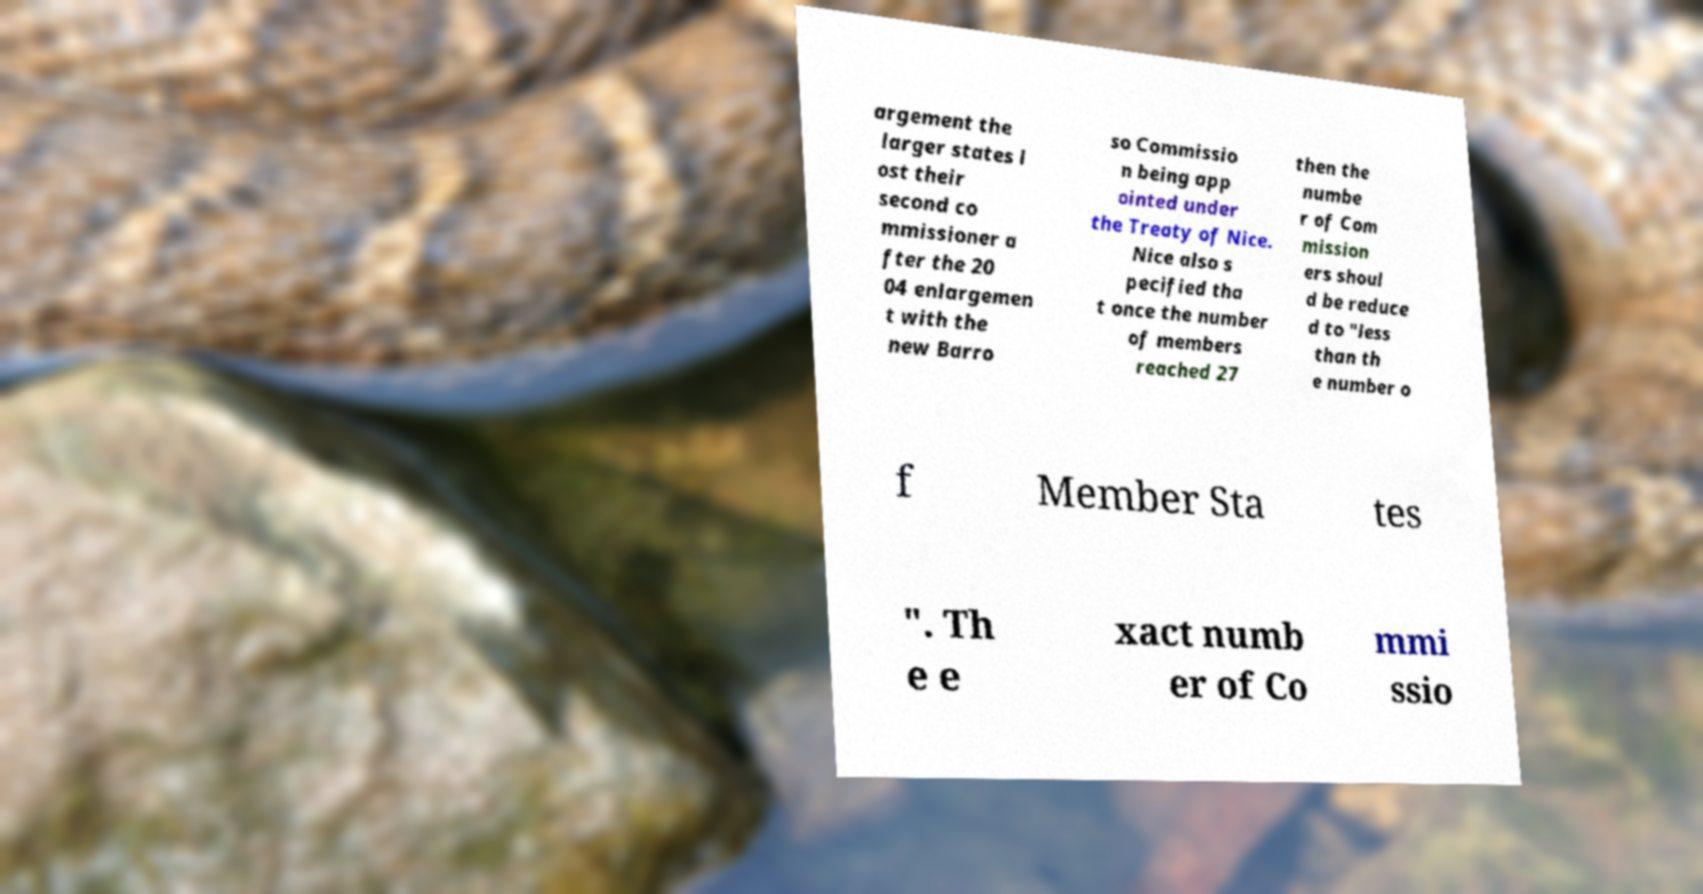I need the written content from this picture converted into text. Can you do that? argement the larger states l ost their second co mmissioner a fter the 20 04 enlargemen t with the new Barro so Commissio n being app ointed under the Treaty of Nice. Nice also s pecified tha t once the number of members reached 27 then the numbe r of Com mission ers shoul d be reduce d to "less than th e number o f Member Sta tes ". Th e e xact numb er of Co mmi ssio 